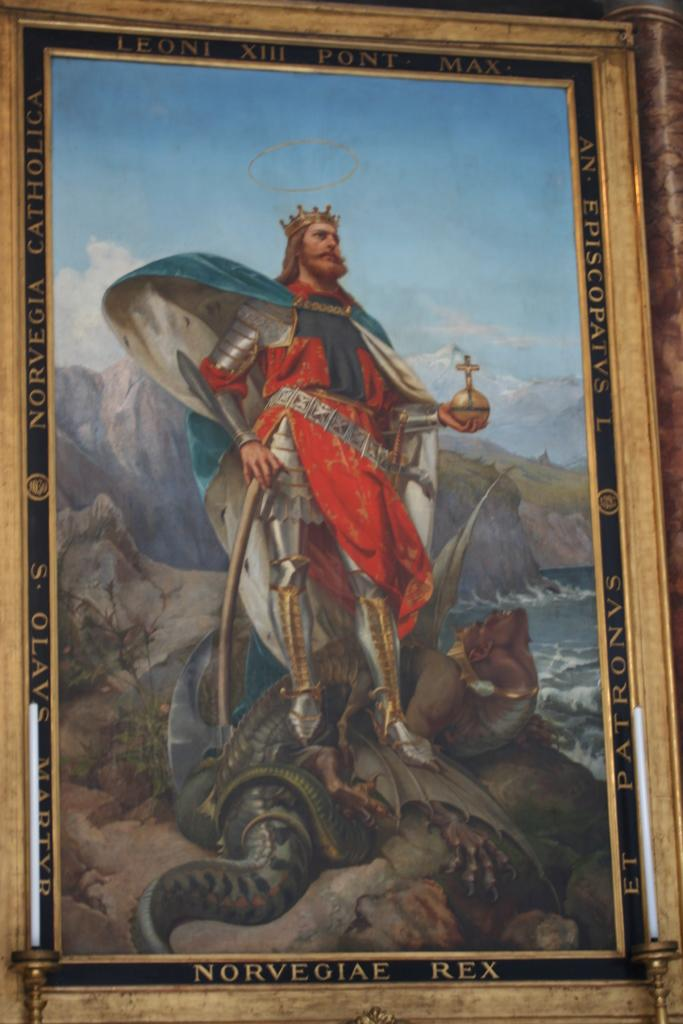<image>
Describe the image concisely. A painting of a crusade era knight wearing a crown and standing atop a slain dragon framed with the words Leone XIII Pont Max at the top. 